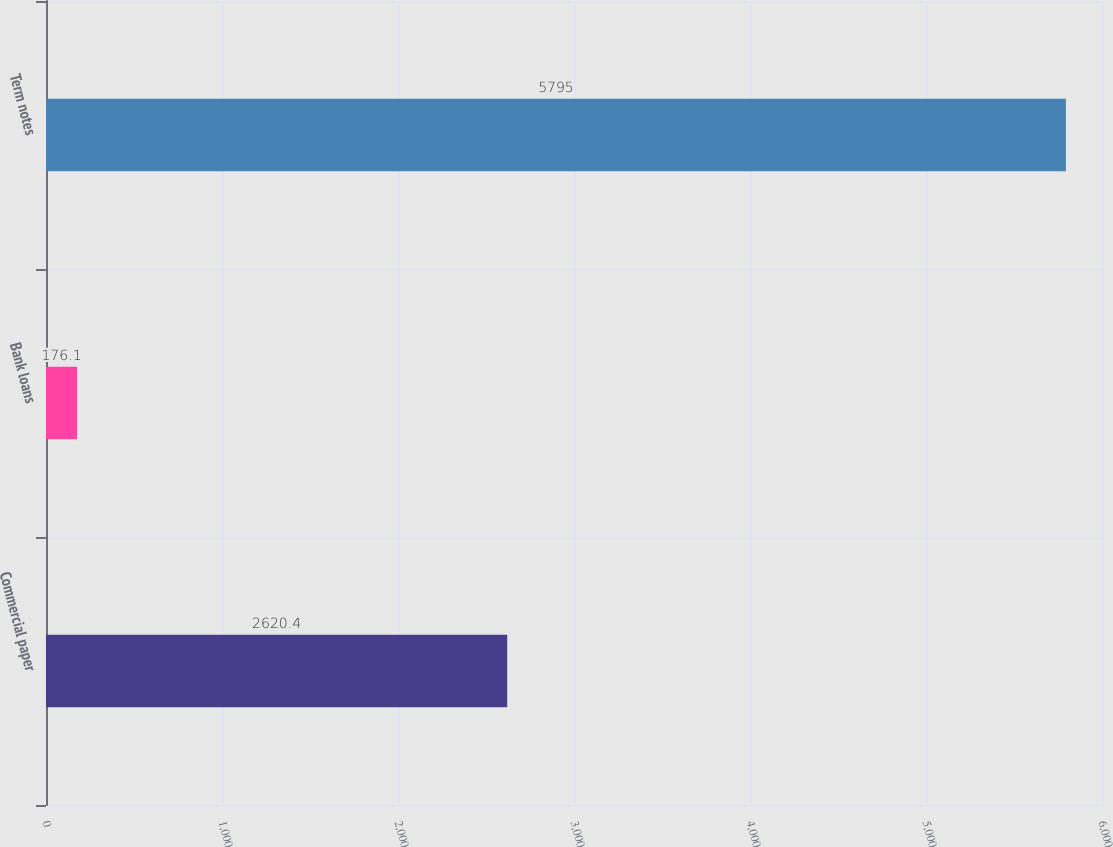Convert chart to OTSL. <chart><loc_0><loc_0><loc_500><loc_500><bar_chart><fcel>Commercial paper<fcel>Bank loans<fcel>Term notes<nl><fcel>2620.4<fcel>176.1<fcel>5795<nl></chart> 